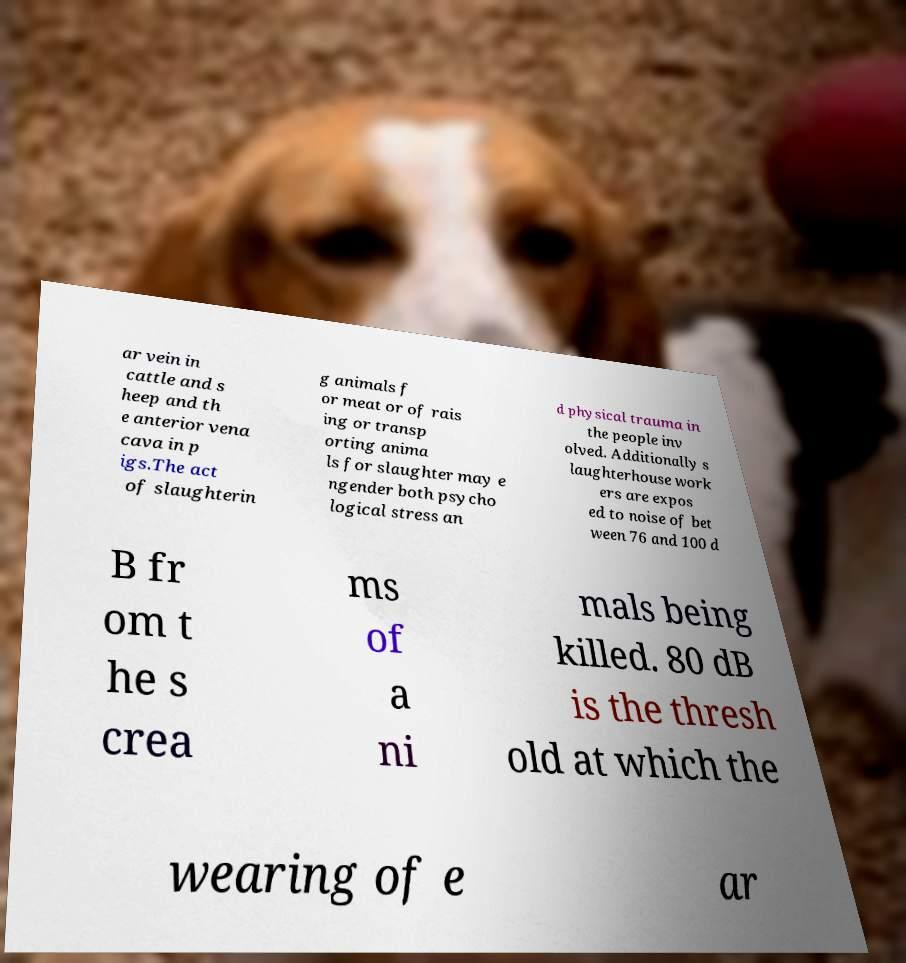What messages or text are displayed in this image? I need them in a readable, typed format. ar vein in cattle and s heep and th e anterior vena cava in p igs.The act of slaughterin g animals f or meat or of rais ing or transp orting anima ls for slaughter may e ngender both psycho logical stress an d physical trauma in the people inv olved. Additionally s laughterhouse work ers are expos ed to noise of bet ween 76 and 100 d B fr om t he s crea ms of a ni mals being killed. 80 dB is the thresh old at which the wearing of e ar 